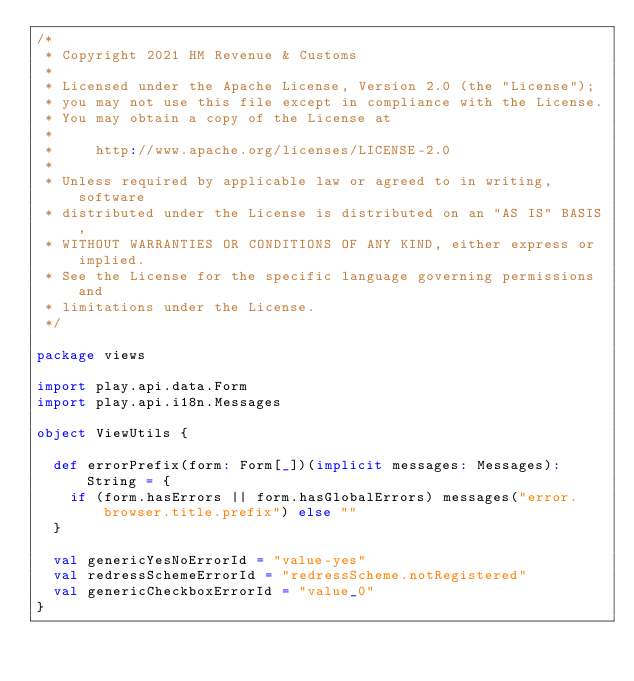<code> <loc_0><loc_0><loc_500><loc_500><_Scala_>/*
 * Copyright 2021 HM Revenue & Customs
 *
 * Licensed under the Apache License, Version 2.0 (the "License");
 * you may not use this file except in compliance with the License.
 * You may obtain a copy of the License at
 *
 *     http://www.apache.org/licenses/LICENSE-2.0
 *
 * Unless required by applicable law or agreed to in writing, software
 * distributed under the License is distributed on an "AS IS" BASIS,
 * WITHOUT WARRANTIES OR CONDITIONS OF ANY KIND, either express or implied.
 * See the License for the specific language governing permissions and
 * limitations under the License.
 */

package views

import play.api.data.Form
import play.api.i18n.Messages

object ViewUtils {

  def errorPrefix(form: Form[_])(implicit messages: Messages): String = {
    if (form.hasErrors || form.hasGlobalErrors) messages("error.browser.title.prefix") else ""
  }

  val genericYesNoErrorId = "value-yes"
  val redressSchemeErrorId = "redressScheme.notRegistered"
  val genericCheckboxErrorId = "value_0"
}
</code> 